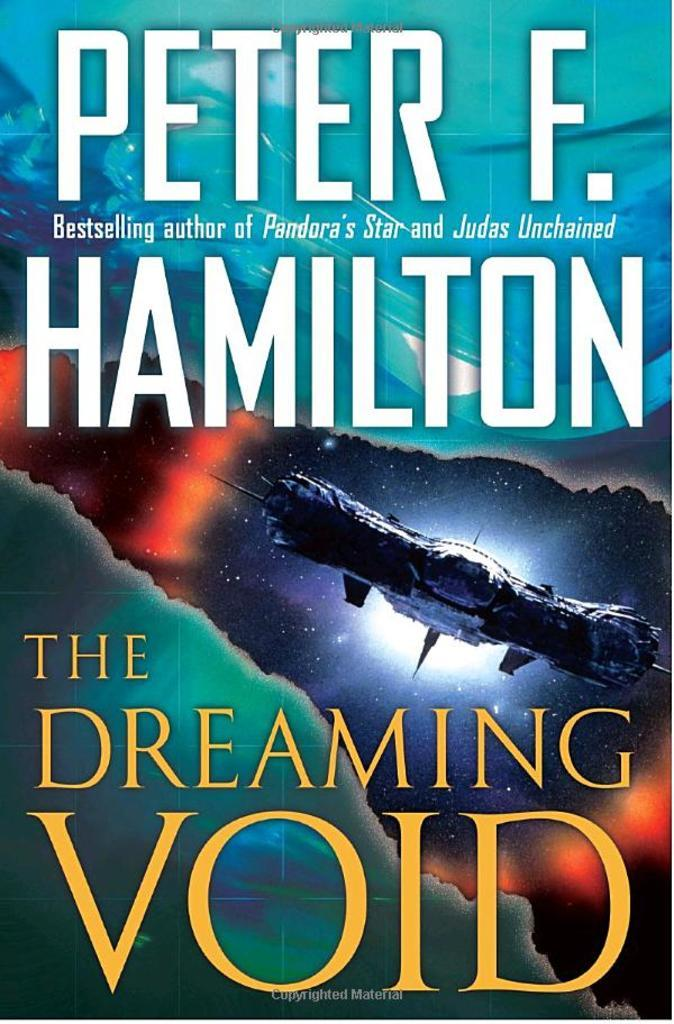Provide a one-sentence caption for the provided image. A book cover for a sci-fi novel called The Dreaming Void. 